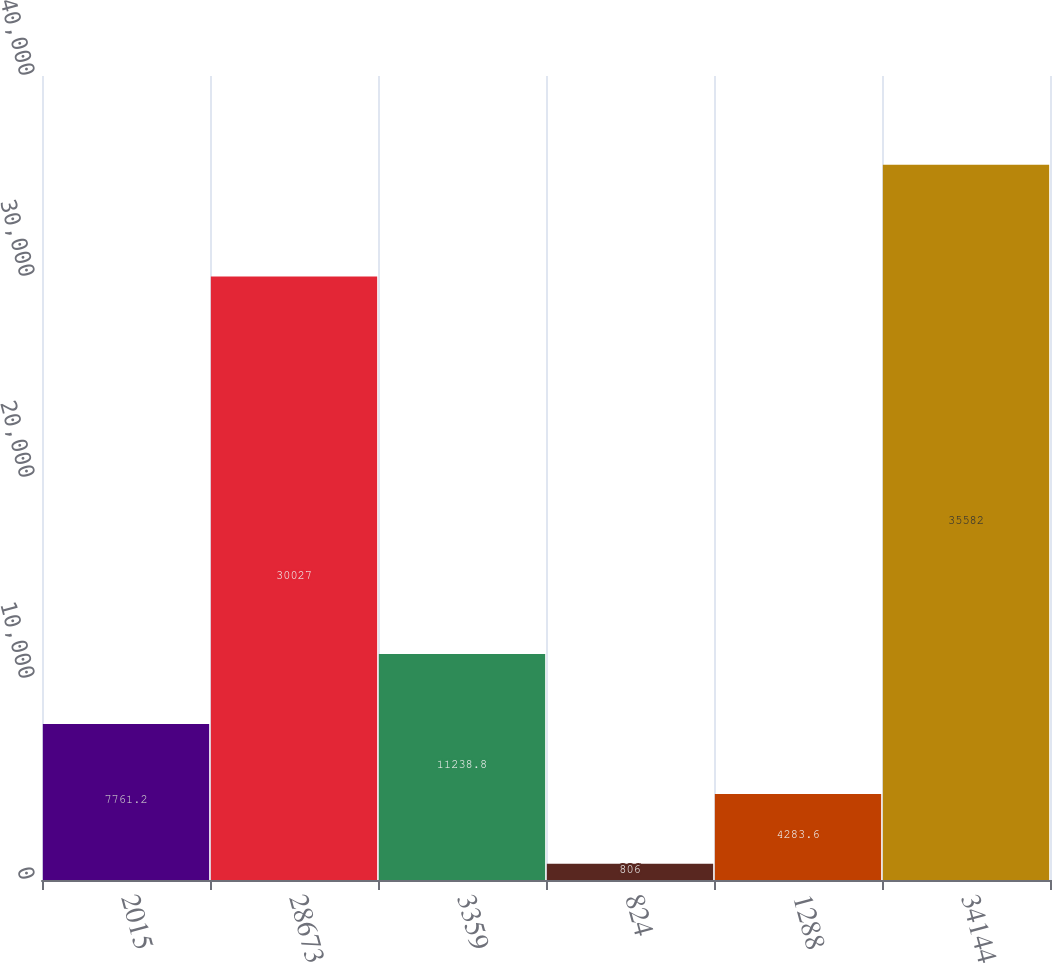Convert chart. <chart><loc_0><loc_0><loc_500><loc_500><bar_chart><fcel>2015<fcel>28673<fcel>3359<fcel>824<fcel>1288<fcel>34144<nl><fcel>7761.2<fcel>30027<fcel>11238.8<fcel>806<fcel>4283.6<fcel>35582<nl></chart> 